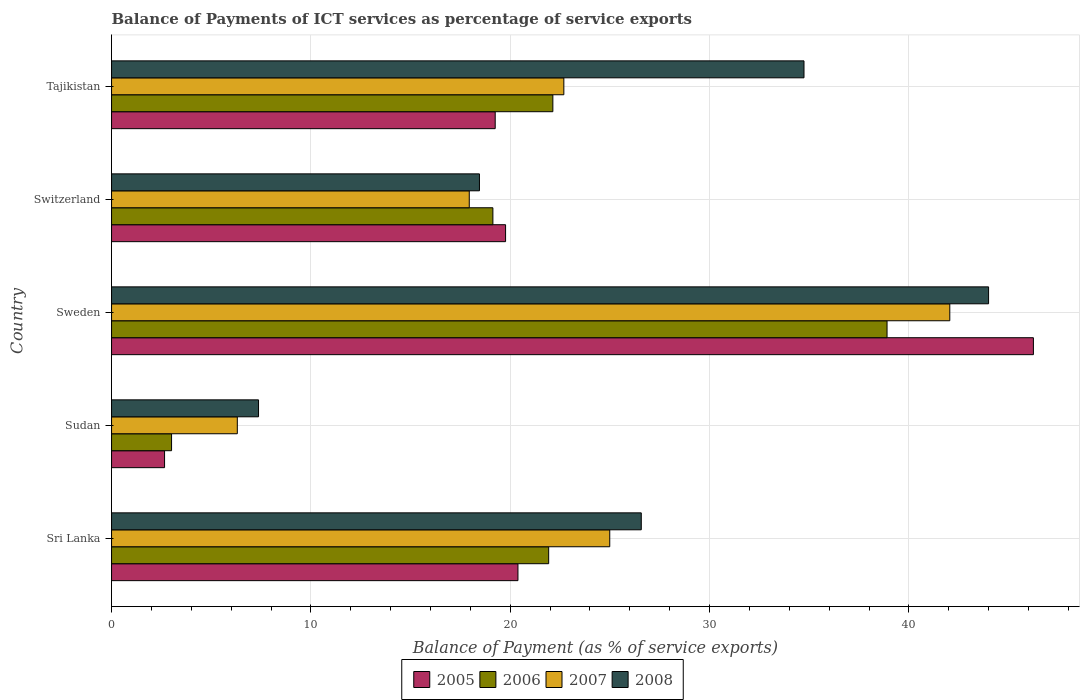How many different coloured bars are there?
Provide a short and direct response. 4. How many bars are there on the 3rd tick from the top?
Ensure brevity in your answer.  4. What is the label of the 5th group of bars from the top?
Ensure brevity in your answer.  Sri Lanka. In how many cases, is the number of bars for a given country not equal to the number of legend labels?
Provide a short and direct response. 0. What is the balance of payments of ICT services in 2008 in Switzerland?
Provide a short and direct response. 18.46. Across all countries, what is the maximum balance of payments of ICT services in 2008?
Your answer should be very brief. 44. Across all countries, what is the minimum balance of payments of ICT services in 2005?
Offer a terse response. 2.66. In which country was the balance of payments of ICT services in 2006 maximum?
Your answer should be very brief. Sweden. In which country was the balance of payments of ICT services in 2005 minimum?
Offer a terse response. Sudan. What is the total balance of payments of ICT services in 2006 in the graph?
Your answer should be very brief. 105.11. What is the difference between the balance of payments of ICT services in 2006 in Sri Lanka and that in Sweden?
Give a very brief answer. -16.98. What is the difference between the balance of payments of ICT services in 2007 in Switzerland and the balance of payments of ICT services in 2005 in Sweden?
Your answer should be very brief. -28.3. What is the average balance of payments of ICT services in 2005 per country?
Give a very brief answer. 21.66. What is the difference between the balance of payments of ICT services in 2006 and balance of payments of ICT services in 2008 in Sudan?
Your answer should be compact. -4.36. In how many countries, is the balance of payments of ICT services in 2008 greater than 40 %?
Offer a terse response. 1. What is the ratio of the balance of payments of ICT services in 2005 in Sri Lanka to that in Sweden?
Make the answer very short. 0.44. Is the balance of payments of ICT services in 2007 in Sweden less than that in Tajikistan?
Your response must be concise. No. What is the difference between the highest and the second highest balance of payments of ICT services in 2007?
Provide a short and direct response. 17.06. What is the difference between the highest and the lowest balance of payments of ICT services in 2007?
Keep it short and to the point. 35.74. In how many countries, is the balance of payments of ICT services in 2006 greater than the average balance of payments of ICT services in 2006 taken over all countries?
Your response must be concise. 3. What does the 1st bar from the top in Tajikistan represents?
Keep it short and to the point. 2008. What does the 3rd bar from the bottom in Sweden represents?
Keep it short and to the point. 2007. Is it the case that in every country, the sum of the balance of payments of ICT services in 2007 and balance of payments of ICT services in 2008 is greater than the balance of payments of ICT services in 2005?
Offer a very short reply. Yes. What is the title of the graph?
Your answer should be compact. Balance of Payments of ICT services as percentage of service exports. Does "2004" appear as one of the legend labels in the graph?
Ensure brevity in your answer.  No. What is the label or title of the X-axis?
Offer a terse response. Balance of Payment (as % of service exports). What is the Balance of Payment (as % of service exports) in 2005 in Sri Lanka?
Your response must be concise. 20.39. What is the Balance of Payment (as % of service exports) in 2006 in Sri Lanka?
Provide a short and direct response. 21.93. What is the Balance of Payment (as % of service exports) of 2007 in Sri Lanka?
Your answer should be compact. 24.99. What is the Balance of Payment (as % of service exports) of 2008 in Sri Lanka?
Your answer should be very brief. 26.57. What is the Balance of Payment (as % of service exports) in 2005 in Sudan?
Offer a very short reply. 2.66. What is the Balance of Payment (as % of service exports) of 2006 in Sudan?
Your answer should be very brief. 3.01. What is the Balance of Payment (as % of service exports) in 2007 in Sudan?
Your response must be concise. 6.31. What is the Balance of Payment (as % of service exports) of 2008 in Sudan?
Keep it short and to the point. 7.37. What is the Balance of Payment (as % of service exports) in 2005 in Sweden?
Your answer should be compact. 46.24. What is the Balance of Payment (as % of service exports) of 2006 in Sweden?
Make the answer very short. 38.9. What is the Balance of Payment (as % of service exports) of 2007 in Sweden?
Give a very brief answer. 42.05. What is the Balance of Payment (as % of service exports) of 2008 in Sweden?
Ensure brevity in your answer.  44. What is the Balance of Payment (as % of service exports) of 2005 in Switzerland?
Provide a succinct answer. 19.77. What is the Balance of Payment (as % of service exports) in 2006 in Switzerland?
Provide a succinct answer. 19.13. What is the Balance of Payment (as % of service exports) of 2007 in Switzerland?
Give a very brief answer. 17.94. What is the Balance of Payment (as % of service exports) of 2008 in Switzerland?
Your answer should be very brief. 18.46. What is the Balance of Payment (as % of service exports) in 2005 in Tajikistan?
Provide a short and direct response. 19.25. What is the Balance of Payment (as % of service exports) of 2006 in Tajikistan?
Keep it short and to the point. 22.14. What is the Balance of Payment (as % of service exports) in 2007 in Tajikistan?
Give a very brief answer. 22.69. What is the Balance of Payment (as % of service exports) of 2008 in Tajikistan?
Your answer should be very brief. 34.74. Across all countries, what is the maximum Balance of Payment (as % of service exports) in 2005?
Your response must be concise. 46.24. Across all countries, what is the maximum Balance of Payment (as % of service exports) in 2006?
Keep it short and to the point. 38.9. Across all countries, what is the maximum Balance of Payment (as % of service exports) in 2007?
Offer a very short reply. 42.05. Across all countries, what is the maximum Balance of Payment (as % of service exports) in 2008?
Make the answer very short. 44. Across all countries, what is the minimum Balance of Payment (as % of service exports) in 2005?
Your answer should be compact. 2.66. Across all countries, what is the minimum Balance of Payment (as % of service exports) of 2006?
Your answer should be very brief. 3.01. Across all countries, what is the minimum Balance of Payment (as % of service exports) in 2007?
Ensure brevity in your answer.  6.31. Across all countries, what is the minimum Balance of Payment (as % of service exports) in 2008?
Provide a short and direct response. 7.37. What is the total Balance of Payment (as % of service exports) in 2005 in the graph?
Give a very brief answer. 108.3. What is the total Balance of Payment (as % of service exports) of 2006 in the graph?
Your response must be concise. 105.11. What is the total Balance of Payment (as % of service exports) of 2007 in the graph?
Give a very brief answer. 113.98. What is the total Balance of Payment (as % of service exports) of 2008 in the graph?
Make the answer very short. 131.13. What is the difference between the Balance of Payment (as % of service exports) of 2005 in Sri Lanka and that in Sudan?
Your answer should be very brief. 17.73. What is the difference between the Balance of Payment (as % of service exports) of 2006 in Sri Lanka and that in Sudan?
Offer a terse response. 18.92. What is the difference between the Balance of Payment (as % of service exports) of 2007 in Sri Lanka and that in Sudan?
Ensure brevity in your answer.  18.68. What is the difference between the Balance of Payment (as % of service exports) of 2008 in Sri Lanka and that in Sudan?
Provide a succinct answer. 19.2. What is the difference between the Balance of Payment (as % of service exports) of 2005 in Sri Lanka and that in Sweden?
Ensure brevity in your answer.  -25.86. What is the difference between the Balance of Payment (as % of service exports) of 2006 in Sri Lanka and that in Sweden?
Your response must be concise. -16.98. What is the difference between the Balance of Payment (as % of service exports) of 2007 in Sri Lanka and that in Sweden?
Offer a terse response. -17.06. What is the difference between the Balance of Payment (as % of service exports) of 2008 in Sri Lanka and that in Sweden?
Your response must be concise. -17.42. What is the difference between the Balance of Payment (as % of service exports) in 2005 in Sri Lanka and that in Switzerland?
Make the answer very short. 0.62. What is the difference between the Balance of Payment (as % of service exports) of 2006 in Sri Lanka and that in Switzerland?
Your answer should be very brief. 2.8. What is the difference between the Balance of Payment (as % of service exports) in 2007 in Sri Lanka and that in Switzerland?
Keep it short and to the point. 7.05. What is the difference between the Balance of Payment (as % of service exports) of 2008 in Sri Lanka and that in Switzerland?
Ensure brevity in your answer.  8.12. What is the difference between the Balance of Payment (as % of service exports) of 2005 in Sri Lanka and that in Tajikistan?
Offer a terse response. 1.14. What is the difference between the Balance of Payment (as % of service exports) of 2006 in Sri Lanka and that in Tajikistan?
Your answer should be compact. -0.21. What is the difference between the Balance of Payment (as % of service exports) in 2007 in Sri Lanka and that in Tajikistan?
Keep it short and to the point. 2.3. What is the difference between the Balance of Payment (as % of service exports) of 2008 in Sri Lanka and that in Tajikistan?
Your answer should be very brief. -8.16. What is the difference between the Balance of Payment (as % of service exports) in 2005 in Sudan and that in Sweden?
Provide a succinct answer. -43.58. What is the difference between the Balance of Payment (as % of service exports) of 2006 in Sudan and that in Sweden?
Make the answer very short. -35.89. What is the difference between the Balance of Payment (as % of service exports) in 2007 in Sudan and that in Sweden?
Keep it short and to the point. -35.74. What is the difference between the Balance of Payment (as % of service exports) of 2008 in Sudan and that in Sweden?
Your response must be concise. -36.62. What is the difference between the Balance of Payment (as % of service exports) of 2005 in Sudan and that in Switzerland?
Keep it short and to the point. -17.11. What is the difference between the Balance of Payment (as % of service exports) in 2006 in Sudan and that in Switzerland?
Provide a succinct answer. -16.12. What is the difference between the Balance of Payment (as % of service exports) in 2007 in Sudan and that in Switzerland?
Keep it short and to the point. -11.64. What is the difference between the Balance of Payment (as % of service exports) in 2008 in Sudan and that in Switzerland?
Offer a terse response. -11.08. What is the difference between the Balance of Payment (as % of service exports) in 2005 in Sudan and that in Tajikistan?
Offer a very short reply. -16.59. What is the difference between the Balance of Payment (as % of service exports) of 2006 in Sudan and that in Tajikistan?
Your answer should be very brief. -19.13. What is the difference between the Balance of Payment (as % of service exports) of 2007 in Sudan and that in Tajikistan?
Ensure brevity in your answer.  -16.38. What is the difference between the Balance of Payment (as % of service exports) of 2008 in Sudan and that in Tajikistan?
Offer a very short reply. -27.36. What is the difference between the Balance of Payment (as % of service exports) in 2005 in Sweden and that in Switzerland?
Your answer should be compact. 26.48. What is the difference between the Balance of Payment (as % of service exports) of 2006 in Sweden and that in Switzerland?
Make the answer very short. 19.77. What is the difference between the Balance of Payment (as % of service exports) in 2007 in Sweden and that in Switzerland?
Provide a succinct answer. 24.11. What is the difference between the Balance of Payment (as % of service exports) of 2008 in Sweden and that in Switzerland?
Your response must be concise. 25.54. What is the difference between the Balance of Payment (as % of service exports) of 2005 in Sweden and that in Tajikistan?
Offer a very short reply. 27. What is the difference between the Balance of Payment (as % of service exports) in 2006 in Sweden and that in Tajikistan?
Ensure brevity in your answer.  16.76. What is the difference between the Balance of Payment (as % of service exports) of 2007 in Sweden and that in Tajikistan?
Offer a terse response. 19.36. What is the difference between the Balance of Payment (as % of service exports) in 2008 in Sweden and that in Tajikistan?
Offer a very short reply. 9.26. What is the difference between the Balance of Payment (as % of service exports) in 2005 in Switzerland and that in Tajikistan?
Your response must be concise. 0.52. What is the difference between the Balance of Payment (as % of service exports) in 2006 in Switzerland and that in Tajikistan?
Make the answer very short. -3.01. What is the difference between the Balance of Payment (as % of service exports) of 2007 in Switzerland and that in Tajikistan?
Your answer should be very brief. -4.74. What is the difference between the Balance of Payment (as % of service exports) in 2008 in Switzerland and that in Tajikistan?
Your response must be concise. -16.28. What is the difference between the Balance of Payment (as % of service exports) of 2005 in Sri Lanka and the Balance of Payment (as % of service exports) of 2006 in Sudan?
Ensure brevity in your answer.  17.38. What is the difference between the Balance of Payment (as % of service exports) of 2005 in Sri Lanka and the Balance of Payment (as % of service exports) of 2007 in Sudan?
Your answer should be compact. 14.08. What is the difference between the Balance of Payment (as % of service exports) in 2005 in Sri Lanka and the Balance of Payment (as % of service exports) in 2008 in Sudan?
Your answer should be compact. 13.01. What is the difference between the Balance of Payment (as % of service exports) in 2006 in Sri Lanka and the Balance of Payment (as % of service exports) in 2007 in Sudan?
Make the answer very short. 15.62. What is the difference between the Balance of Payment (as % of service exports) of 2006 in Sri Lanka and the Balance of Payment (as % of service exports) of 2008 in Sudan?
Provide a short and direct response. 14.55. What is the difference between the Balance of Payment (as % of service exports) in 2007 in Sri Lanka and the Balance of Payment (as % of service exports) in 2008 in Sudan?
Provide a succinct answer. 17.62. What is the difference between the Balance of Payment (as % of service exports) in 2005 in Sri Lanka and the Balance of Payment (as % of service exports) in 2006 in Sweden?
Provide a succinct answer. -18.52. What is the difference between the Balance of Payment (as % of service exports) of 2005 in Sri Lanka and the Balance of Payment (as % of service exports) of 2007 in Sweden?
Keep it short and to the point. -21.66. What is the difference between the Balance of Payment (as % of service exports) of 2005 in Sri Lanka and the Balance of Payment (as % of service exports) of 2008 in Sweden?
Provide a succinct answer. -23.61. What is the difference between the Balance of Payment (as % of service exports) of 2006 in Sri Lanka and the Balance of Payment (as % of service exports) of 2007 in Sweden?
Offer a very short reply. -20.12. What is the difference between the Balance of Payment (as % of service exports) of 2006 in Sri Lanka and the Balance of Payment (as % of service exports) of 2008 in Sweden?
Ensure brevity in your answer.  -22.07. What is the difference between the Balance of Payment (as % of service exports) of 2007 in Sri Lanka and the Balance of Payment (as % of service exports) of 2008 in Sweden?
Make the answer very short. -19. What is the difference between the Balance of Payment (as % of service exports) of 2005 in Sri Lanka and the Balance of Payment (as % of service exports) of 2006 in Switzerland?
Your answer should be compact. 1.26. What is the difference between the Balance of Payment (as % of service exports) in 2005 in Sri Lanka and the Balance of Payment (as % of service exports) in 2007 in Switzerland?
Ensure brevity in your answer.  2.44. What is the difference between the Balance of Payment (as % of service exports) in 2005 in Sri Lanka and the Balance of Payment (as % of service exports) in 2008 in Switzerland?
Provide a succinct answer. 1.93. What is the difference between the Balance of Payment (as % of service exports) in 2006 in Sri Lanka and the Balance of Payment (as % of service exports) in 2007 in Switzerland?
Your answer should be compact. 3.98. What is the difference between the Balance of Payment (as % of service exports) of 2006 in Sri Lanka and the Balance of Payment (as % of service exports) of 2008 in Switzerland?
Make the answer very short. 3.47. What is the difference between the Balance of Payment (as % of service exports) of 2007 in Sri Lanka and the Balance of Payment (as % of service exports) of 2008 in Switzerland?
Offer a terse response. 6.54. What is the difference between the Balance of Payment (as % of service exports) in 2005 in Sri Lanka and the Balance of Payment (as % of service exports) in 2006 in Tajikistan?
Provide a succinct answer. -1.75. What is the difference between the Balance of Payment (as % of service exports) of 2005 in Sri Lanka and the Balance of Payment (as % of service exports) of 2007 in Tajikistan?
Your answer should be very brief. -2.3. What is the difference between the Balance of Payment (as % of service exports) in 2005 in Sri Lanka and the Balance of Payment (as % of service exports) in 2008 in Tajikistan?
Your answer should be compact. -14.35. What is the difference between the Balance of Payment (as % of service exports) in 2006 in Sri Lanka and the Balance of Payment (as % of service exports) in 2007 in Tajikistan?
Give a very brief answer. -0.76. What is the difference between the Balance of Payment (as % of service exports) of 2006 in Sri Lanka and the Balance of Payment (as % of service exports) of 2008 in Tajikistan?
Offer a very short reply. -12.81. What is the difference between the Balance of Payment (as % of service exports) of 2007 in Sri Lanka and the Balance of Payment (as % of service exports) of 2008 in Tajikistan?
Your answer should be very brief. -9.74. What is the difference between the Balance of Payment (as % of service exports) in 2005 in Sudan and the Balance of Payment (as % of service exports) in 2006 in Sweden?
Ensure brevity in your answer.  -36.24. What is the difference between the Balance of Payment (as % of service exports) of 2005 in Sudan and the Balance of Payment (as % of service exports) of 2007 in Sweden?
Your response must be concise. -39.39. What is the difference between the Balance of Payment (as % of service exports) of 2005 in Sudan and the Balance of Payment (as % of service exports) of 2008 in Sweden?
Provide a succinct answer. -41.34. What is the difference between the Balance of Payment (as % of service exports) in 2006 in Sudan and the Balance of Payment (as % of service exports) in 2007 in Sweden?
Offer a terse response. -39.04. What is the difference between the Balance of Payment (as % of service exports) of 2006 in Sudan and the Balance of Payment (as % of service exports) of 2008 in Sweden?
Make the answer very short. -40.99. What is the difference between the Balance of Payment (as % of service exports) in 2007 in Sudan and the Balance of Payment (as % of service exports) in 2008 in Sweden?
Keep it short and to the point. -37.69. What is the difference between the Balance of Payment (as % of service exports) in 2005 in Sudan and the Balance of Payment (as % of service exports) in 2006 in Switzerland?
Offer a terse response. -16.47. What is the difference between the Balance of Payment (as % of service exports) of 2005 in Sudan and the Balance of Payment (as % of service exports) of 2007 in Switzerland?
Provide a succinct answer. -15.28. What is the difference between the Balance of Payment (as % of service exports) of 2005 in Sudan and the Balance of Payment (as % of service exports) of 2008 in Switzerland?
Provide a short and direct response. -15.8. What is the difference between the Balance of Payment (as % of service exports) of 2006 in Sudan and the Balance of Payment (as % of service exports) of 2007 in Switzerland?
Your response must be concise. -14.93. What is the difference between the Balance of Payment (as % of service exports) in 2006 in Sudan and the Balance of Payment (as % of service exports) in 2008 in Switzerland?
Give a very brief answer. -15.45. What is the difference between the Balance of Payment (as % of service exports) in 2007 in Sudan and the Balance of Payment (as % of service exports) in 2008 in Switzerland?
Your response must be concise. -12.15. What is the difference between the Balance of Payment (as % of service exports) of 2005 in Sudan and the Balance of Payment (as % of service exports) of 2006 in Tajikistan?
Provide a succinct answer. -19.48. What is the difference between the Balance of Payment (as % of service exports) in 2005 in Sudan and the Balance of Payment (as % of service exports) in 2007 in Tajikistan?
Make the answer very short. -20.03. What is the difference between the Balance of Payment (as % of service exports) in 2005 in Sudan and the Balance of Payment (as % of service exports) in 2008 in Tajikistan?
Offer a terse response. -32.08. What is the difference between the Balance of Payment (as % of service exports) in 2006 in Sudan and the Balance of Payment (as % of service exports) in 2007 in Tajikistan?
Keep it short and to the point. -19.68. What is the difference between the Balance of Payment (as % of service exports) of 2006 in Sudan and the Balance of Payment (as % of service exports) of 2008 in Tajikistan?
Offer a terse response. -31.73. What is the difference between the Balance of Payment (as % of service exports) in 2007 in Sudan and the Balance of Payment (as % of service exports) in 2008 in Tajikistan?
Offer a very short reply. -28.43. What is the difference between the Balance of Payment (as % of service exports) in 2005 in Sweden and the Balance of Payment (as % of service exports) in 2006 in Switzerland?
Ensure brevity in your answer.  27.11. What is the difference between the Balance of Payment (as % of service exports) of 2005 in Sweden and the Balance of Payment (as % of service exports) of 2007 in Switzerland?
Provide a succinct answer. 28.3. What is the difference between the Balance of Payment (as % of service exports) of 2005 in Sweden and the Balance of Payment (as % of service exports) of 2008 in Switzerland?
Offer a terse response. 27.79. What is the difference between the Balance of Payment (as % of service exports) of 2006 in Sweden and the Balance of Payment (as % of service exports) of 2007 in Switzerland?
Your response must be concise. 20.96. What is the difference between the Balance of Payment (as % of service exports) in 2006 in Sweden and the Balance of Payment (as % of service exports) in 2008 in Switzerland?
Provide a short and direct response. 20.45. What is the difference between the Balance of Payment (as % of service exports) in 2007 in Sweden and the Balance of Payment (as % of service exports) in 2008 in Switzerland?
Offer a terse response. 23.59. What is the difference between the Balance of Payment (as % of service exports) in 2005 in Sweden and the Balance of Payment (as % of service exports) in 2006 in Tajikistan?
Provide a succinct answer. 24.11. What is the difference between the Balance of Payment (as % of service exports) in 2005 in Sweden and the Balance of Payment (as % of service exports) in 2007 in Tajikistan?
Offer a terse response. 23.56. What is the difference between the Balance of Payment (as % of service exports) of 2005 in Sweden and the Balance of Payment (as % of service exports) of 2008 in Tajikistan?
Provide a short and direct response. 11.51. What is the difference between the Balance of Payment (as % of service exports) of 2006 in Sweden and the Balance of Payment (as % of service exports) of 2007 in Tajikistan?
Provide a short and direct response. 16.21. What is the difference between the Balance of Payment (as % of service exports) of 2006 in Sweden and the Balance of Payment (as % of service exports) of 2008 in Tajikistan?
Ensure brevity in your answer.  4.17. What is the difference between the Balance of Payment (as % of service exports) of 2007 in Sweden and the Balance of Payment (as % of service exports) of 2008 in Tajikistan?
Give a very brief answer. 7.31. What is the difference between the Balance of Payment (as % of service exports) of 2005 in Switzerland and the Balance of Payment (as % of service exports) of 2006 in Tajikistan?
Offer a very short reply. -2.37. What is the difference between the Balance of Payment (as % of service exports) of 2005 in Switzerland and the Balance of Payment (as % of service exports) of 2007 in Tajikistan?
Ensure brevity in your answer.  -2.92. What is the difference between the Balance of Payment (as % of service exports) of 2005 in Switzerland and the Balance of Payment (as % of service exports) of 2008 in Tajikistan?
Offer a terse response. -14.97. What is the difference between the Balance of Payment (as % of service exports) in 2006 in Switzerland and the Balance of Payment (as % of service exports) in 2007 in Tajikistan?
Ensure brevity in your answer.  -3.56. What is the difference between the Balance of Payment (as % of service exports) in 2006 in Switzerland and the Balance of Payment (as % of service exports) in 2008 in Tajikistan?
Offer a terse response. -15.61. What is the difference between the Balance of Payment (as % of service exports) of 2007 in Switzerland and the Balance of Payment (as % of service exports) of 2008 in Tajikistan?
Your response must be concise. -16.79. What is the average Balance of Payment (as % of service exports) in 2005 per country?
Provide a succinct answer. 21.66. What is the average Balance of Payment (as % of service exports) of 2006 per country?
Ensure brevity in your answer.  21.02. What is the average Balance of Payment (as % of service exports) of 2007 per country?
Give a very brief answer. 22.8. What is the average Balance of Payment (as % of service exports) in 2008 per country?
Ensure brevity in your answer.  26.23. What is the difference between the Balance of Payment (as % of service exports) of 2005 and Balance of Payment (as % of service exports) of 2006 in Sri Lanka?
Your response must be concise. -1.54. What is the difference between the Balance of Payment (as % of service exports) in 2005 and Balance of Payment (as % of service exports) in 2007 in Sri Lanka?
Keep it short and to the point. -4.61. What is the difference between the Balance of Payment (as % of service exports) in 2005 and Balance of Payment (as % of service exports) in 2008 in Sri Lanka?
Ensure brevity in your answer.  -6.19. What is the difference between the Balance of Payment (as % of service exports) in 2006 and Balance of Payment (as % of service exports) in 2007 in Sri Lanka?
Give a very brief answer. -3.06. What is the difference between the Balance of Payment (as % of service exports) of 2006 and Balance of Payment (as % of service exports) of 2008 in Sri Lanka?
Your answer should be very brief. -4.65. What is the difference between the Balance of Payment (as % of service exports) in 2007 and Balance of Payment (as % of service exports) in 2008 in Sri Lanka?
Your answer should be very brief. -1.58. What is the difference between the Balance of Payment (as % of service exports) in 2005 and Balance of Payment (as % of service exports) in 2006 in Sudan?
Provide a succinct answer. -0.35. What is the difference between the Balance of Payment (as % of service exports) in 2005 and Balance of Payment (as % of service exports) in 2007 in Sudan?
Provide a succinct answer. -3.65. What is the difference between the Balance of Payment (as % of service exports) in 2005 and Balance of Payment (as % of service exports) in 2008 in Sudan?
Provide a short and direct response. -4.71. What is the difference between the Balance of Payment (as % of service exports) in 2006 and Balance of Payment (as % of service exports) in 2007 in Sudan?
Offer a terse response. -3.3. What is the difference between the Balance of Payment (as % of service exports) of 2006 and Balance of Payment (as % of service exports) of 2008 in Sudan?
Ensure brevity in your answer.  -4.36. What is the difference between the Balance of Payment (as % of service exports) of 2007 and Balance of Payment (as % of service exports) of 2008 in Sudan?
Ensure brevity in your answer.  -1.06. What is the difference between the Balance of Payment (as % of service exports) of 2005 and Balance of Payment (as % of service exports) of 2006 in Sweden?
Offer a terse response. 7.34. What is the difference between the Balance of Payment (as % of service exports) of 2005 and Balance of Payment (as % of service exports) of 2007 in Sweden?
Your answer should be very brief. 4.19. What is the difference between the Balance of Payment (as % of service exports) in 2005 and Balance of Payment (as % of service exports) in 2008 in Sweden?
Provide a short and direct response. 2.25. What is the difference between the Balance of Payment (as % of service exports) in 2006 and Balance of Payment (as % of service exports) in 2007 in Sweden?
Offer a very short reply. -3.15. What is the difference between the Balance of Payment (as % of service exports) of 2006 and Balance of Payment (as % of service exports) of 2008 in Sweden?
Provide a succinct answer. -5.09. What is the difference between the Balance of Payment (as % of service exports) in 2007 and Balance of Payment (as % of service exports) in 2008 in Sweden?
Your answer should be very brief. -1.95. What is the difference between the Balance of Payment (as % of service exports) of 2005 and Balance of Payment (as % of service exports) of 2006 in Switzerland?
Make the answer very short. 0.64. What is the difference between the Balance of Payment (as % of service exports) of 2005 and Balance of Payment (as % of service exports) of 2007 in Switzerland?
Make the answer very short. 1.82. What is the difference between the Balance of Payment (as % of service exports) of 2005 and Balance of Payment (as % of service exports) of 2008 in Switzerland?
Provide a succinct answer. 1.31. What is the difference between the Balance of Payment (as % of service exports) of 2006 and Balance of Payment (as % of service exports) of 2007 in Switzerland?
Ensure brevity in your answer.  1.19. What is the difference between the Balance of Payment (as % of service exports) in 2006 and Balance of Payment (as % of service exports) in 2008 in Switzerland?
Offer a terse response. 0.67. What is the difference between the Balance of Payment (as % of service exports) of 2007 and Balance of Payment (as % of service exports) of 2008 in Switzerland?
Offer a terse response. -0.51. What is the difference between the Balance of Payment (as % of service exports) of 2005 and Balance of Payment (as % of service exports) of 2006 in Tajikistan?
Your response must be concise. -2.89. What is the difference between the Balance of Payment (as % of service exports) of 2005 and Balance of Payment (as % of service exports) of 2007 in Tajikistan?
Ensure brevity in your answer.  -3.44. What is the difference between the Balance of Payment (as % of service exports) of 2005 and Balance of Payment (as % of service exports) of 2008 in Tajikistan?
Give a very brief answer. -15.49. What is the difference between the Balance of Payment (as % of service exports) of 2006 and Balance of Payment (as % of service exports) of 2007 in Tajikistan?
Keep it short and to the point. -0.55. What is the difference between the Balance of Payment (as % of service exports) in 2006 and Balance of Payment (as % of service exports) in 2008 in Tajikistan?
Keep it short and to the point. -12.6. What is the difference between the Balance of Payment (as % of service exports) in 2007 and Balance of Payment (as % of service exports) in 2008 in Tajikistan?
Offer a terse response. -12.05. What is the ratio of the Balance of Payment (as % of service exports) of 2005 in Sri Lanka to that in Sudan?
Give a very brief answer. 7.67. What is the ratio of the Balance of Payment (as % of service exports) of 2006 in Sri Lanka to that in Sudan?
Your answer should be very brief. 7.29. What is the ratio of the Balance of Payment (as % of service exports) of 2007 in Sri Lanka to that in Sudan?
Give a very brief answer. 3.96. What is the ratio of the Balance of Payment (as % of service exports) of 2008 in Sri Lanka to that in Sudan?
Provide a short and direct response. 3.6. What is the ratio of the Balance of Payment (as % of service exports) in 2005 in Sri Lanka to that in Sweden?
Your response must be concise. 0.44. What is the ratio of the Balance of Payment (as % of service exports) of 2006 in Sri Lanka to that in Sweden?
Keep it short and to the point. 0.56. What is the ratio of the Balance of Payment (as % of service exports) of 2007 in Sri Lanka to that in Sweden?
Your answer should be compact. 0.59. What is the ratio of the Balance of Payment (as % of service exports) of 2008 in Sri Lanka to that in Sweden?
Your response must be concise. 0.6. What is the ratio of the Balance of Payment (as % of service exports) in 2005 in Sri Lanka to that in Switzerland?
Make the answer very short. 1.03. What is the ratio of the Balance of Payment (as % of service exports) in 2006 in Sri Lanka to that in Switzerland?
Your answer should be very brief. 1.15. What is the ratio of the Balance of Payment (as % of service exports) in 2007 in Sri Lanka to that in Switzerland?
Provide a short and direct response. 1.39. What is the ratio of the Balance of Payment (as % of service exports) in 2008 in Sri Lanka to that in Switzerland?
Provide a short and direct response. 1.44. What is the ratio of the Balance of Payment (as % of service exports) of 2005 in Sri Lanka to that in Tajikistan?
Offer a very short reply. 1.06. What is the ratio of the Balance of Payment (as % of service exports) in 2007 in Sri Lanka to that in Tajikistan?
Your answer should be very brief. 1.1. What is the ratio of the Balance of Payment (as % of service exports) in 2008 in Sri Lanka to that in Tajikistan?
Ensure brevity in your answer.  0.77. What is the ratio of the Balance of Payment (as % of service exports) of 2005 in Sudan to that in Sweden?
Your answer should be very brief. 0.06. What is the ratio of the Balance of Payment (as % of service exports) of 2006 in Sudan to that in Sweden?
Offer a terse response. 0.08. What is the ratio of the Balance of Payment (as % of service exports) in 2008 in Sudan to that in Sweden?
Offer a very short reply. 0.17. What is the ratio of the Balance of Payment (as % of service exports) of 2005 in Sudan to that in Switzerland?
Give a very brief answer. 0.13. What is the ratio of the Balance of Payment (as % of service exports) of 2006 in Sudan to that in Switzerland?
Give a very brief answer. 0.16. What is the ratio of the Balance of Payment (as % of service exports) of 2007 in Sudan to that in Switzerland?
Provide a short and direct response. 0.35. What is the ratio of the Balance of Payment (as % of service exports) of 2008 in Sudan to that in Switzerland?
Offer a terse response. 0.4. What is the ratio of the Balance of Payment (as % of service exports) in 2005 in Sudan to that in Tajikistan?
Ensure brevity in your answer.  0.14. What is the ratio of the Balance of Payment (as % of service exports) of 2006 in Sudan to that in Tajikistan?
Make the answer very short. 0.14. What is the ratio of the Balance of Payment (as % of service exports) of 2007 in Sudan to that in Tajikistan?
Keep it short and to the point. 0.28. What is the ratio of the Balance of Payment (as % of service exports) of 2008 in Sudan to that in Tajikistan?
Ensure brevity in your answer.  0.21. What is the ratio of the Balance of Payment (as % of service exports) of 2005 in Sweden to that in Switzerland?
Your response must be concise. 2.34. What is the ratio of the Balance of Payment (as % of service exports) in 2006 in Sweden to that in Switzerland?
Provide a short and direct response. 2.03. What is the ratio of the Balance of Payment (as % of service exports) of 2007 in Sweden to that in Switzerland?
Provide a short and direct response. 2.34. What is the ratio of the Balance of Payment (as % of service exports) of 2008 in Sweden to that in Switzerland?
Make the answer very short. 2.38. What is the ratio of the Balance of Payment (as % of service exports) in 2005 in Sweden to that in Tajikistan?
Offer a very short reply. 2.4. What is the ratio of the Balance of Payment (as % of service exports) of 2006 in Sweden to that in Tajikistan?
Provide a short and direct response. 1.76. What is the ratio of the Balance of Payment (as % of service exports) in 2007 in Sweden to that in Tajikistan?
Ensure brevity in your answer.  1.85. What is the ratio of the Balance of Payment (as % of service exports) in 2008 in Sweden to that in Tajikistan?
Provide a succinct answer. 1.27. What is the ratio of the Balance of Payment (as % of service exports) in 2005 in Switzerland to that in Tajikistan?
Your answer should be compact. 1.03. What is the ratio of the Balance of Payment (as % of service exports) of 2006 in Switzerland to that in Tajikistan?
Your answer should be very brief. 0.86. What is the ratio of the Balance of Payment (as % of service exports) in 2007 in Switzerland to that in Tajikistan?
Make the answer very short. 0.79. What is the ratio of the Balance of Payment (as % of service exports) of 2008 in Switzerland to that in Tajikistan?
Your response must be concise. 0.53. What is the difference between the highest and the second highest Balance of Payment (as % of service exports) of 2005?
Make the answer very short. 25.86. What is the difference between the highest and the second highest Balance of Payment (as % of service exports) of 2006?
Make the answer very short. 16.76. What is the difference between the highest and the second highest Balance of Payment (as % of service exports) of 2007?
Provide a short and direct response. 17.06. What is the difference between the highest and the second highest Balance of Payment (as % of service exports) of 2008?
Offer a very short reply. 9.26. What is the difference between the highest and the lowest Balance of Payment (as % of service exports) of 2005?
Keep it short and to the point. 43.58. What is the difference between the highest and the lowest Balance of Payment (as % of service exports) of 2006?
Provide a succinct answer. 35.89. What is the difference between the highest and the lowest Balance of Payment (as % of service exports) of 2007?
Provide a succinct answer. 35.74. What is the difference between the highest and the lowest Balance of Payment (as % of service exports) of 2008?
Keep it short and to the point. 36.62. 